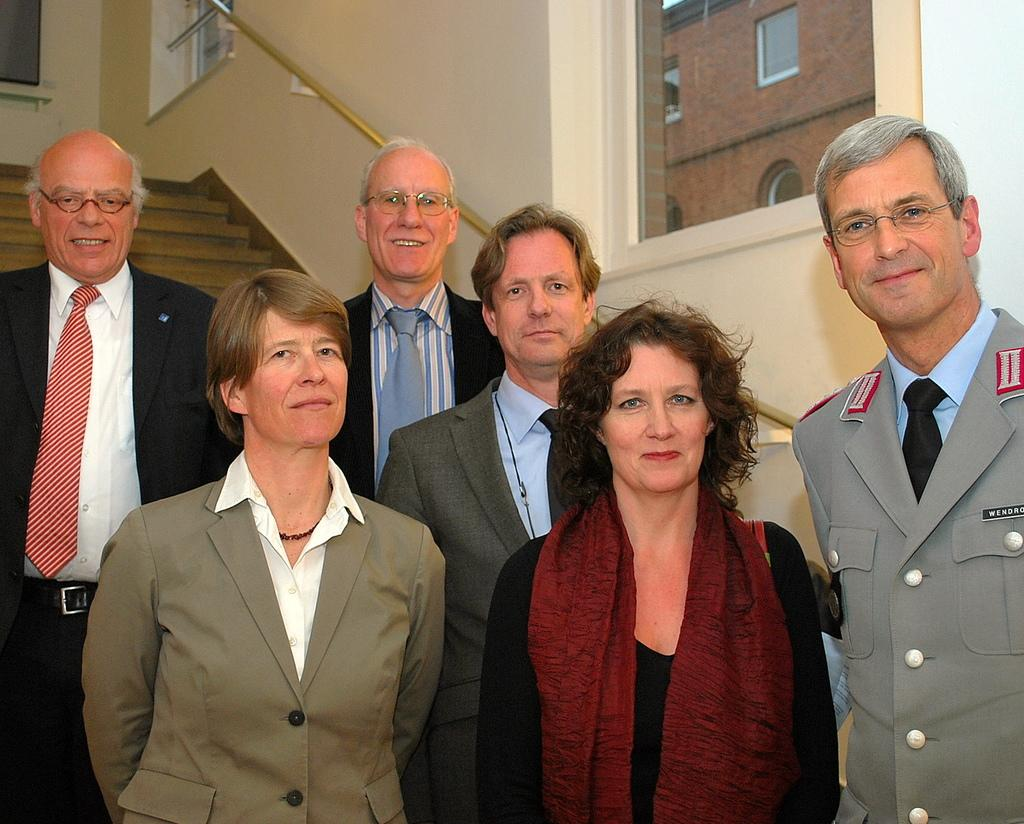What is happening in the image? There are people standing in the image. What can be seen in the background of the image? There are steps, a rod, a wall, and glass windows in the background of the image. What is visible through the glass windows? There is a wall and additional windows visible through the glass windows. What type of beast can be seen using the apparatus in the image? There is no beast or apparatus present in the image. What view can be seen from the windows in the image? The provided facts do not mention a view visible from the windows, only the presence of a wall and additional windows. 